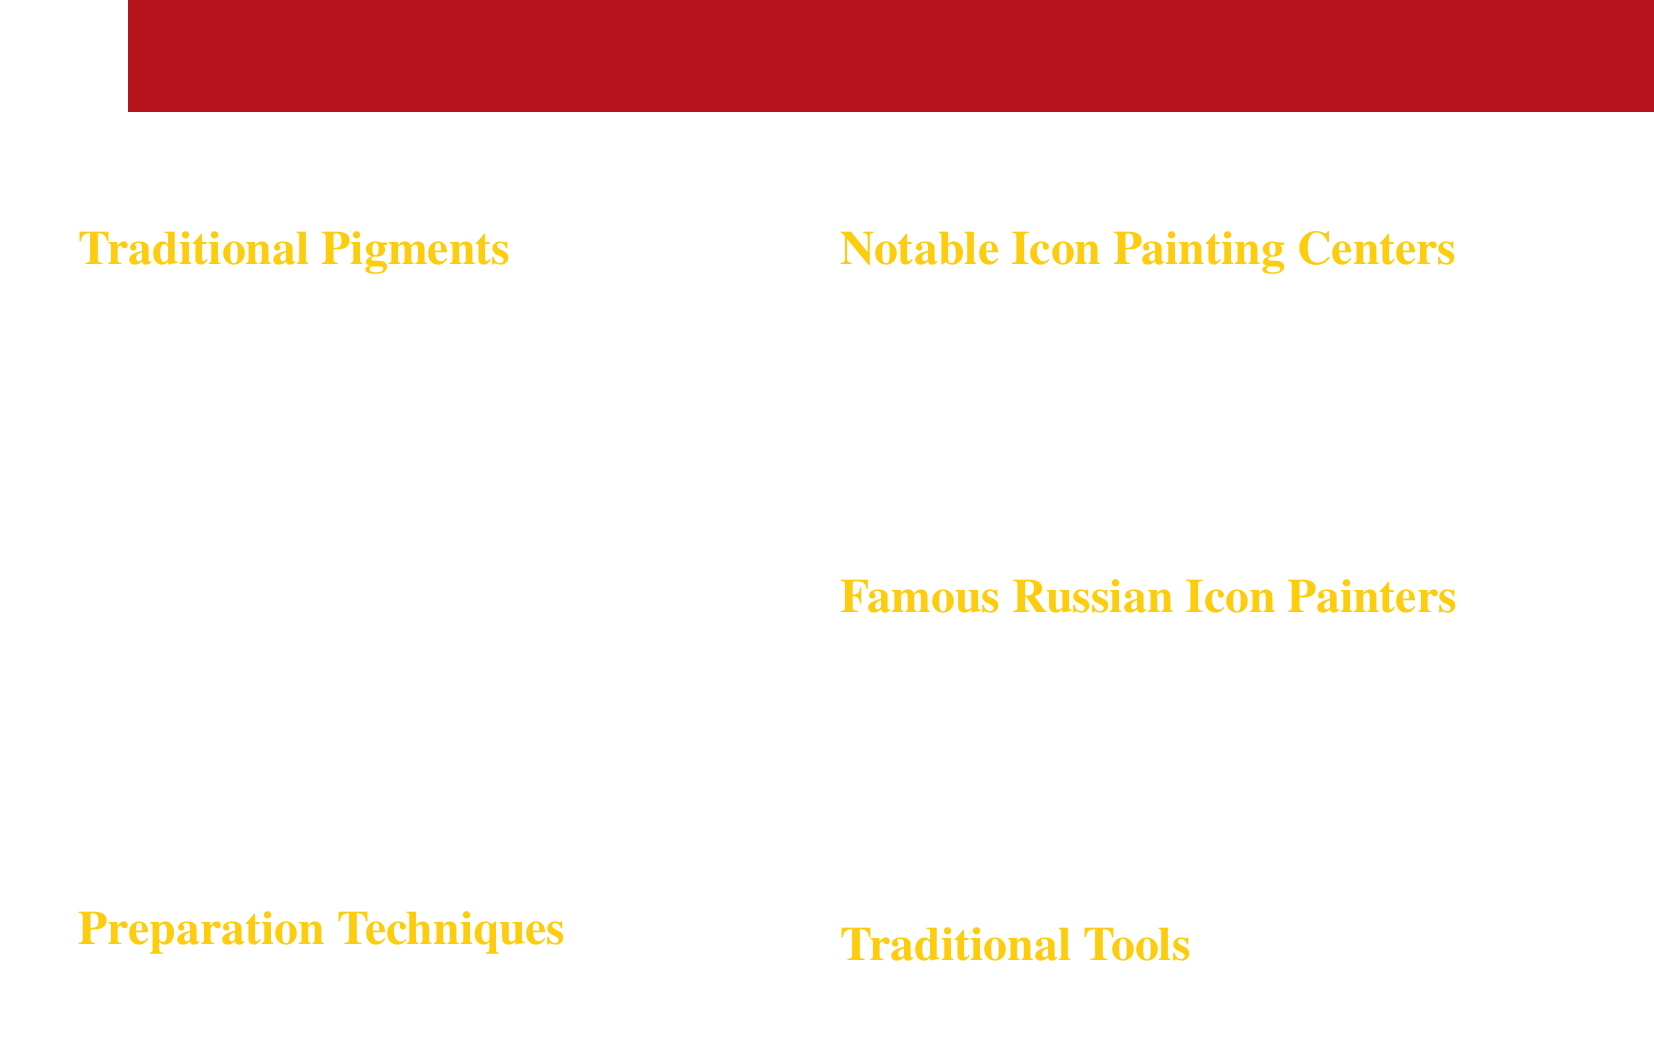What is the color of Cinnabar? The document states that Cinnabar is bright red in color.
Answer: Bright red Which pigment is used for highlights? Lead White is specified as essential for highlights in the document.
Answer: Lead White What are the sources of Azurite? The document mentions that Azurite is sourced from copper carbonate mineral.
Answer: Copper carbonate mineral Name one traditional tool mentioned in the document. The document lists squirrel hair brushes as a traditional tool used in icon painting.
Answer: Squirrel hair brushes Which school is NOT listed as a notable icon painting center? The question implies identifying a school not mentioned, and since only Novgorod, Moscow, and Pskov are listed, any other school would work.
Answer: Any other school (e.g., "Kazan School") What is a preparation technique for pigments? The document states that grinding pigments with egg yolk is a preparation technique.
Answer: Grinding pigments with egg yolk Who is one famous Russian icon painter mentioned? The document lists Andrei Rublev as a famous Russian icon painter.
Answer: Andrei Rublev Which color pigment is derived from iron oxide? The document states that Ochre is derived from iron oxide-rich clay deposits.
Answer: Ochre What is the significance of Malachite in icon painting? Malachite is used for vegetation and some clothing in icons, according to the document.
Answer: Vegetation and clothing 